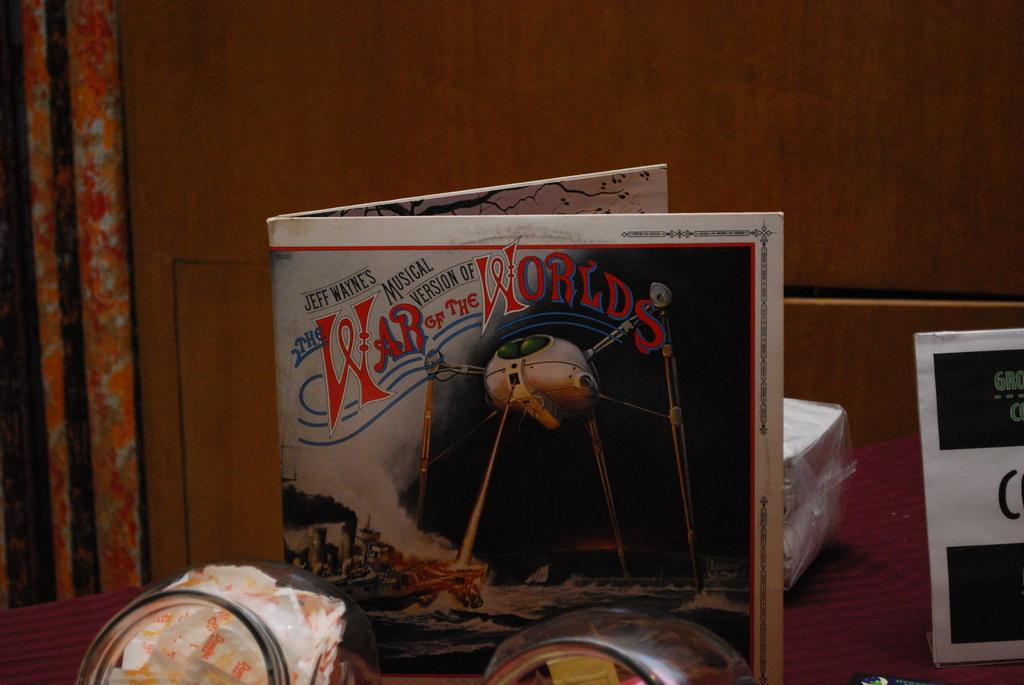<image>
Provide a brief description of the given image. A book sits on a table that has a picture of a spaceship and says War Of The Worlds above it. 